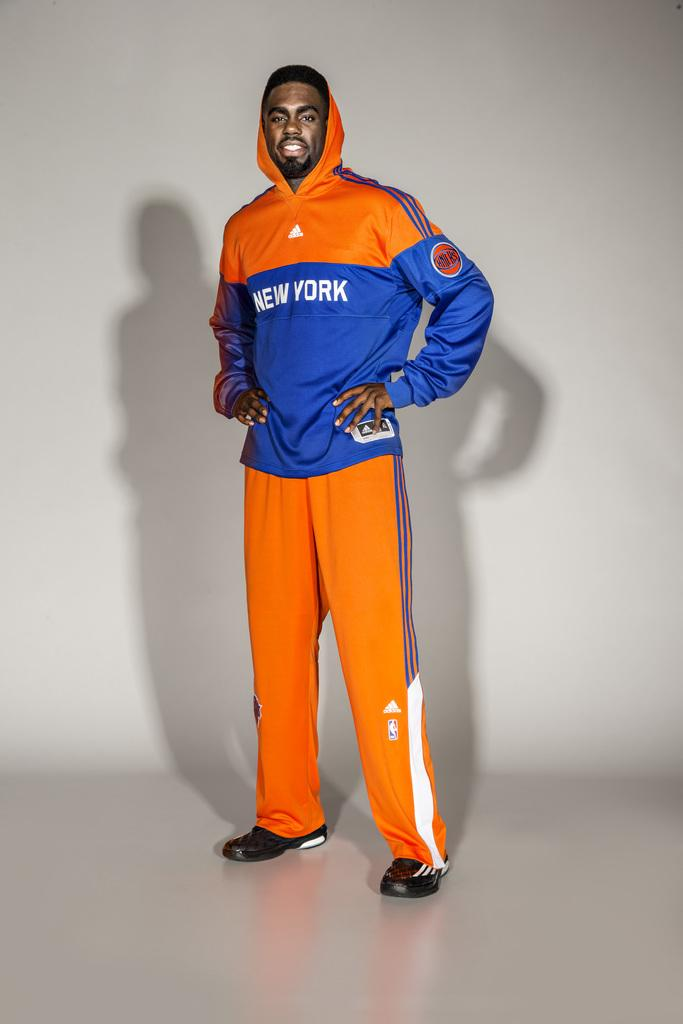Who or what is present in the image? There is a person in the image. What is the person wearing? The person is wearing an orange and blue jacket. What is the person's facial expression? The person is smiling. What can be seen in the background of the image? There are shadows of the person on the wall in the background. Can you see a duck in the image? No, there is no duck present in the image. 